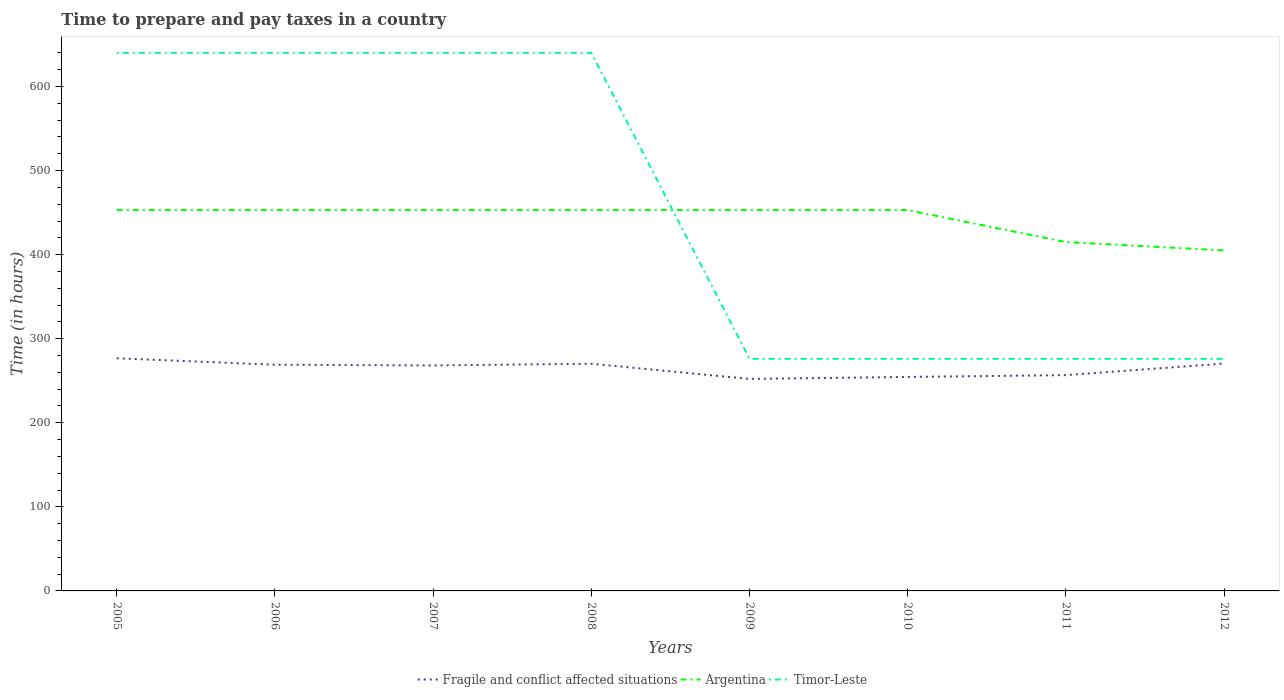Does the line corresponding to Fragile and conflict affected situations intersect with the line corresponding to Argentina?
Keep it short and to the point. No. Across all years, what is the maximum number of hours required to prepare and pay taxes in Timor-Leste?
Keep it short and to the point. 276. What is the total number of hours required to prepare and pay taxes in Argentina in the graph?
Give a very brief answer. 0. What is the difference between the highest and the second highest number of hours required to prepare and pay taxes in Timor-Leste?
Ensure brevity in your answer.  364. How many lines are there?
Provide a succinct answer. 3. Does the graph contain any zero values?
Give a very brief answer. No. Does the graph contain grids?
Your answer should be compact. No. Where does the legend appear in the graph?
Your answer should be very brief. Bottom center. What is the title of the graph?
Offer a very short reply. Time to prepare and pay taxes in a country. Does "Cyprus" appear as one of the legend labels in the graph?
Offer a terse response. No. What is the label or title of the Y-axis?
Ensure brevity in your answer.  Time (in hours). What is the Time (in hours) of Fragile and conflict affected situations in 2005?
Keep it short and to the point. 276.75. What is the Time (in hours) in Argentina in 2005?
Give a very brief answer. 453. What is the Time (in hours) of Timor-Leste in 2005?
Provide a short and direct response. 640. What is the Time (in hours) in Fragile and conflict affected situations in 2006?
Provide a short and direct response. 269.07. What is the Time (in hours) of Argentina in 2006?
Your answer should be compact. 453. What is the Time (in hours) of Timor-Leste in 2006?
Keep it short and to the point. 640. What is the Time (in hours) in Fragile and conflict affected situations in 2007?
Offer a terse response. 268.17. What is the Time (in hours) in Argentina in 2007?
Provide a short and direct response. 453. What is the Time (in hours) of Timor-Leste in 2007?
Your answer should be very brief. 640. What is the Time (in hours) in Fragile and conflict affected situations in 2008?
Offer a very short reply. 270.24. What is the Time (in hours) in Argentina in 2008?
Keep it short and to the point. 453. What is the Time (in hours) in Timor-Leste in 2008?
Your answer should be compact. 640. What is the Time (in hours) in Fragile and conflict affected situations in 2009?
Your answer should be compact. 252.17. What is the Time (in hours) of Argentina in 2009?
Offer a very short reply. 453. What is the Time (in hours) in Timor-Leste in 2009?
Offer a very short reply. 276. What is the Time (in hours) of Fragile and conflict affected situations in 2010?
Provide a succinct answer. 254.53. What is the Time (in hours) in Argentina in 2010?
Provide a succinct answer. 453. What is the Time (in hours) in Timor-Leste in 2010?
Provide a short and direct response. 276. What is the Time (in hours) in Fragile and conflict affected situations in 2011?
Ensure brevity in your answer.  256.68. What is the Time (in hours) in Argentina in 2011?
Provide a succinct answer. 415. What is the Time (in hours) in Timor-Leste in 2011?
Your answer should be compact. 276. What is the Time (in hours) in Fragile and conflict affected situations in 2012?
Provide a succinct answer. 270.48. What is the Time (in hours) in Argentina in 2012?
Your answer should be compact. 405. What is the Time (in hours) in Timor-Leste in 2012?
Provide a short and direct response. 276. Across all years, what is the maximum Time (in hours) of Fragile and conflict affected situations?
Ensure brevity in your answer.  276.75. Across all years, what is the maximum Time (in hours) of Argentina?
Give a very brief answer. 453. Across all years, what is the maximum Time (in hours) of Timor-Leste?
Your answer should be very brief. 640. Across all years, what is the minimum Time (in hours) in Fragile and conflict affected situations?
Provide a succinct answer. 252.17. Across all years, what is the minimum Time (in hours) in Argentina?
Your response must be concise. 405. Across all years, what is the minimum Time (in hours) in Timor-Leste?
Give a very brief answer. 276. What is the total Time (in hours) in Fragile and conflict affected situations in the graph?
Provide a succinct answer. 2118.1. What is the total Time (in hours) of Argentina in the graph?
Your answer should be compact. 3538. What is the total Time (in hours) of Timor-Leste in the graph?
Offer a terse response. 3664. What is the difference between the Time (in hours) in Fragile and conflict affected situations in 2005 and that in 2006?
Offer a very short reply. 7.68. What is the difference between the Time (in hours) of Timor-Leste in 2005 and that in 2006?
Your response must be concise. 0. What is the difference between the Time (in hours) in Fragile and conflict affected situations in 2005 and that in 2007?
Ensure brevity in your answer.  8.58. What is the difference between the Time (in hours) of Timor-Leste in 2005 and that in 2007?
Offer a terse response. 0. What is the difference between the Time (in hours) in Fragile and conflict affected situations in 2005 and that in 2008?
Provide a succinct answer. 6.51. What is the difference between the Time (in hours) of Timor-Leste in 2005 and that in 2008?
Keep it short and to the point. 0. What is the difference between the Time (in hours) in Fragile and conflict affected situations in 2005 and that in 2009?
Provide a short and direct response. 24.58. What is the difference between the Time (in hours) in Argentina in 2005 and that in 2009?
Your response must be concise. 0. What is the difference between the Time (in hours) in Timor-Leste in 2005 and that in 2009?
Provide a succinct answer. 364. What is the difference between the Time (in hours) of Fragile and conflict affected situations in 2005 and that in 2010?
Offer a very short reply. 22.22. What is the difference between the Time (in hours) in Argentina in 2005 and that in 2010?
Your answer should be very brief. 0. What is the difference between the Time (in hours) of Timor-Leste in 2005 and that in 2010?
Ensure brevity in your answer.  364. What is the difference between the Time (in hours) of Fragile and conflict affected situations in 2005 and that in 2011?
Offer a terse response. 20.07. What is the difference between the Time (in hours) of Timor-Leste in 2005 and that in 2011?
Your answer should be very brief. 364. What is the difference between the Time (in hours) in Fragile and conflict affected situations in 2005 and that in 2012?
Offer a terse response. 6.27. What is the difference between the Time (in hours) of Argentina in 2005 and that in 2012?
Ensure brevity in your answer.  48. What is the difference between the Time (in hours) in Timor-Leste in 2005 and that in 2012?
Provide a succinct answer. 364. What is the difference between the Time (in hours) of Fragile and conflict affected situations in 2006 and that in 2007?
Your answer should be compact. 0.9. What is the difference between the Time (in hours) of Fragile and conflict affected situations in 2006 and that in 2008?
Offer a terse response. -1.17. What is the difference between the Time (in hours) in Timor-Leste in 2006 and that in 2008?
Your answer should be compact. 0. What is the difference between the Time (in hours) in Fragile and conflict affected situations in 2006 and that in 2009?
Your answer should be compact. 16.9. What is the difference between the Time (in hours) in Timor-Leste in 2006 and that in 2009?
Offer a very short reply. 364. What is the difference between the Time (in hours) in Fragile and conflict affected situations in 2006 and that in 2010?
Your answer should be very brief. 14.54. What is the difference between the Time (in hours) of Timor-Leste in 2006 and that in 2010?
Keep it short and to the point. 364. What is the difference between the Time (in hours) in Fragile and conflict affected situations in 2006 and that in 2011?
Offer a very short reply. 12.39. What is the difference between the Time (in hours) in Argentina in 2006 and that in 2011?
Provide a succinct answer. 38. What is the difference between the Time (in hours) in Timor-Leste in 2006 and that in 2011?
Provide a short and direct response. 364. What is the difference between the Time (in hours) of Fragile and conflict affected situations in 2006 and that in 2012?
Offer a terse response. -1.42. What is the difference between the Time (in hours) of Timor-Leste in 2006 and that in 2012?
Your answer should be compact. 364. What is the difference between the Time (in hours) in Fragile and conflict affected situations in 2007 and that in 2008?
Ensure brevity in your answer.  -2.07. What is the difference between the Time (in hours) of Argentina in 2007 and that in 2008?
Give a very brief answer. 0. What is the difference between the Time (in hours) in Timor-Leste in 2007 and that in 2008?
Offer a very short reply. 0. What is the difference between the Time (in hours) in Fragile and conflict affected situations in 2007 and that in 2009?
Your answer should be very brief. 16.01. What is the difference between the Time (in hours) in Argentina in 2007 and that in 2009?
Offer a very short reply. 0. What is the difference between the Time (in hours) in Timor-Leste in 2007 and that in 2009?
Make the answer very short. 364. What is the difference between the Time (in hours) in Fragile and conflict affected situations in 2007 and that in 2010?
Offer a very short reply. 13.64. What is the difference between the Time (in hours) of Argentina in 2007 and that in 2010?
Give a very brief answer. 0. What is the difference between the Time (in hours) of Timor-Leste in 2007 and that in 2010?
Make the answer very short. 364. What is the difference between the Time (in hours) in Fragile and conflict affected situations in 2007 and that in 2011?
Your answer should be very brief. 11.49. What is the difference between the Time (in hours) of Timor-Leste in 2007 and that in 2011?
Offer a very short reply. 364. What is the difference between the Time (in hours) of Fragile and conflict affected situations in 2007 and that in 2012?
Provide a succinct answer. -2.31. What is the difference between the Time (in hours) of Argentina in 2007 and that in 2012?
Ensure brevity in your answer.  48. What is the difference between the Time (in hours) in Timor-Leste in 2007 and that in 2012?
Keep it short and to the point. 364. What is the difference between the Time (in hours) in Fragile and conflict affected situations in 2008 and that in 2009?
Offer a terse response. 18.07. What is the difference between the Time (in hours) in Argentina in 2008 and that in 2009?
Provide a short and direct response. 0. What is the difference between the Time (in hours) of Timor-Leste in 2008 and that in 2009?
Give a very brief answer. 364. What is the difference between the Time (in hours) in Fragile and conflict affected situations in 2008 and that in 2010?
Your answer should be compact. 15.71. What is the difference between the Time (in hours) of Argentina in 2008 and that in 2010?
Offer a terse response. 0. What is the difference between the Time (in hours) in Timor-Leste in 2008 and that in 2010?
Keep it short and to the point. 364. What is the difference between the Time (in hours) in Fragile and conflict affected situations in 2008 and that in 2011?
Provide a short and direct response. 13.56. What is the difference between the Time (in hours) of Timor-Leste in 2008 and that in 2011?
Your answer should be very brief. 364. What is the difference between the Time (in hours) in Fragile and conflict affected situations in 2008 and that in 2012?
Provide a short and direct response. -0.24. What is the difference between the Time (in hours) in Argentina in 2008 and that in 2012?
Make the answer very short. 48. What is the difference between the Time (in hours) of Timor-Leste in 2008 and that in 2012?
Provide a short and direct response. 364. What is the difference between the Time (in hours) of Fragile and conflict affected situations in 2009 and that in 2010?
Provide a short and direct response. -2.37. What is the difference between the Time (in hours) of Argentina in 2009 and that in 2010?
Offer a very short reply. 0. What is the difference between the Time (in hours) in Fragile and conflict affected situations in 2009 and that in 2011?
Give a very brief answer. -4.52. What is the difference between the Time (in hours) of Argentina in 2009 and that in 2011?
Your response must be concise. 38. What is the difference between the Time (in hours) in Timor-Leste in 2009 and that in 2011?
Give a very brief answer. 0. What is the difference between the Time (in hours) of Fragile and conflict affected situations in 2009 and that in 2012?
Your answer should be compact. -18.32. What is the difference between the Time (in hours) in Argentina in 2009 and that in 2012?
Your answer should be compact. 48. What is the difference between the Time (in hours) in Fragile and conflict affected situations in 2010 and that in 2011?
Offer a very short reply. -2.15. What is the difference between the Time (in hours) in Argentina in 2010 and that in 2011?
Ensure brevity in your answer.  38. What is the difference between the Time (in hours) in Fragile and conflict affected situations in 2010 and that in 2012?
Offer a terse response. -15.95. What is the difference between the Time (in hours) of Fragile and conflict affected situations in 2011 and that in 2012?
Offer a very short reply. -13.8. What is the difference between the Time (in hours) of Argentina in 2011 and that in 2012?
Your response must be concise. 10. What is the difference between the Time (in hours) in Timor-Leste in 2011 and that in 2012?
Your answer should be compact. 0. What is the difference between the Time (in hours) in Fragile and conflict affected situations in 2005 and the Time (in hours) in Argentina in 2006?
Keep it short and to the point. -176.25. What is the difference between the Time (in hours) in Fragile and conflict affected situations in 2005 and the Time (in hours) in Timor-Leste in 2006?
Offer a very short reply. -363.25. What is the difference between the Time (in hours) of Argentina in 2005 and the Time (in hours) of Timor-Leste in 2006?
Provide a short and direct response. -187. What is the difference between the Time (in hours) in Fragile and conflict affected situations in 2005 and the Time (in hours) in Argentina in 2007?
Give a very brief answer. -176.25. What is the difference between the Time (in hours) in Fragile and conflict affected situations in 2005 and the Time (in hours) in Timor-Leste in 2007?
Give a very brief answer. -363.25. What is the difference between the Time (in hours) of Argentina in 2005 and the Time (in hours) of Timor-Leste in 2007?
Give a very brief answer. -187. What is the difference between the Time (in hours) in Fragile and conflict affected situations in 2005 and the Time (in hours) in Argentina in 2008?
Make the answer very short. -176.25. What is the difference between the Time (in hours) of Fragile and conflict affected situations in 2005 and the Time (in hours) of Timor-Leste in 2008?
Provide a succinct answer. -363.25. What is the difference between the Time (in hours) of Argentina in 2005 and the Time (in hours) of Timor-Leste in 2008?
Your answer should be very brief. -187. What is the difference between the Time (in hours) in Fragile and conflict affected situations in 2005 and the Time (in hours) in Argentina in 2009?
Provide a short and direct response. -176.25. What is the difference between the Time (in hours) in Fragile and conflict affected situations in 2005 and the Time (in hours) in Timor-Leste in 2009?
Offer a very short reply. 0.75. What is the difference between the Time (in hours) in Argentina in 2005 and the Time (in hours) in Timor-Leste in 2009?
Your answer should be very brief. 177. What is the difference between the Time (in hours) in Fragile and conflict affected situations in 2005 and the Time (in hours) in Argentina in 2010?
Keep it short and to the point. -176.25. What is the difference between the Time (in hours) of Fragile and conflict affected situations in 2005 and the Time (in hours) of Timor-Leste in 2010?
Offer a very short reply. 0.75. What is the difference between the Time (in hours) of Argentina in 2005 and the Time (in hours) of Timor-Leste in 2010?
Ensure brevity in your answer.  177. What is the difference between the Time (in hours) of Fragile and conflict affected situations in 2005 and the Time (in hours) of Argentina in 2011?
Provide a short and direct response. -138.25. What is the difference between the Time (in hours) in Fragile and conflict affected situations in 2005 and the Time (in hours) in Timor-Leste in 2011?
Provide a short and direct response. 0.75. What is the difference between the Time (in hours) in Argentina in 2005 and the Time (in hours) in Timor-Leste in 2011?
Make the answer very short. 177. What is the difference between the Time (in hours) of Fragile and conflict affected situations in 2005 and the Time (in hours) of Argentina in 2012?
Provide a short and direct response. -128.25. What is the difference between the Time (in hours) of Argentina in 2005 and the Time (in hours) of Timor-Leste in 2012?
Offer a terse response. 177. What is the difference between the Time (in hours) of Fragile and conflict affected situations in 2006 and the Time (in hours) of Argentina in 2007?
Make the answer very short. -183.93. What is the difference between the Time (in hours) of Fragile and conflict affected situations in 2006 and the Time (in hours) of Timor-Leste in 2007?
Keep it short and to the point. -370.93. What is the difference between the Time (in hours) of Argentina in 2006 and the Time (in hours) of Timor-Leste in 2007?
Offer a terse response. -187. What is the difference between the Time (in hours) in Fragile and conflict affected situations in 2006 and the Time (in hours) in Argentina in 2008?
Keep it short and to the point. -183.93. What is the difference between the Time (in hours) in Fragile and conflict affected situations in 2006 and the Time (in hours) in Timor-Leste in 2008?
Give a very brief answer. -370.93. What is the difference between the Time (in hours) in Argentina in 2006 and the Time (in hours) in Timor-Leste in 2008?
Keep it short and to the point. -187. What is the difference between the Time (in hours) of Fragile and conflict affected situations in 2006 and the Time (in hours) of Argentina in 2009?
Provide a succinct answer. -183.93. What is the difference between the Time (in hours) in Fragile and conflict affected situations in 2006 and the Time (in hours) in Timor-Leste in 2009?
Make the answer very short. -6.93. What is the difference between the Time (in hours) of Argentina in 2006 and the Time (in hours) of Timor-Leste in 2009?
Offer a terse response. 177. What is the difference between the Time (in hours) in Fragile and conflict affected situations in 2006 and the Time (in hours) in Argentina in 2010?
Give a very brief answer. -183.93. What is the difference between the Time (in hours) of Fragile and conflict affected situations in 2006 and the Time (in hours) of Timor-Leste in 2010?
Your answer should be very brief. -6.93. What is the difference between the Time (in hours) in Argentina in 2006 and the Time (in hours) in Timor-Leste in 2010?
Your answer should be compact. 177. What is the difference between the Time (in hours) in Fragile and conflict affected situations in 2006 and the Time (in hours) in Argentina in 2011?
Your answer should be compact. -145.93. What is the difference between the Time (in hours) of Fragile and conflict affected situations in 2006 and the Time (in hours) of Timor-Leste in 2011?
Your response must be concise. -6.93. What is the difference between the Time (in hours) of Argentina in 2006 and the Time (in hours) of Timor-Leste in 2011?
Offer a terse response. 177. What is the difference between the Time (in hours) in Fragile and conflict affected situations in 2006 and the Time (in hours) in Argentina in 2012?
Your answer should be very brief. -135.93. What is the difference between the Time (in hours) of Fragile and conflict affected situations in 2006 and the Time (in hours) of Timor-Leste in 2012?
Your answer should be very brief. -6.93. What is the difference between the Time (in hours) in Argentina in 2006 and the Time (in hours) in Timor-Leste in 2012?
Your answer should be compact. 177. What is the difference between the Time (in hours) in Fragile and conflict affected situations in 2007 and the Time (in hours) in Argentina in 2008?
Ensure brevity in your answer.  -184.83. What is the difference between the Time (in hours) of Fragile and conflict affected situations in 2007 and the Time (in hours) of Timor-Leste in 2008?
Give a very brief answer. -371.83. What is the difference between the Time (in hours) in Argentina in 2007 and the Time (in hours) in Timor-Leste in 2008?
Make the answer very short. -187. What is the difference between the Time (in hours) in Fragile and conflict affected situations in 2007 and the Time (in hours) in Argentina in 2009?
Make the answer very short. -184.83. What is the difference between the Time (in hours) of Fragile and conflict affected situations in 2007 and the Time (in hours) of Timor-Leste in 2009?
Keep it short and to the point. -7.83. What is the difference between the Time (in hours) in Argentina in 2007 and the Time (in hours) in Timor-Leste in 2009?
Your answer should be very brief. 177. What is the difference between the Time (in hours) in Fragile and conflict affected situations in 2007 and the Time (in hours) in Argentina in 2010?
Your answer should be very brief. -184.83. What is the difference between the Time (in hours) in Fragile and conflict affected situations in 2007 and the Time (in hours) in Timor-Leste in 2010?
Keep it short and to the point. -7.83. What is the difference between the Time (in hours) of Argentina in 2007 and the Time (in hours) of Timor-Leste in 2010?
Ensure brevity in your answer.  177. What is the difference between the Time (in hours) of Fragile and conflict affected situations in 2007 and the Time (in hours) of Argentina in 2011?
Your answer should be very brief. -146.83. What is the difference between the Time (in hours) of Fragile and conflict affected situations in 2007 and the Time (in hours) of Timor-Leste in 2011?
Ensure brevity in your answer.  -7.83. What is the difference between the Time (in hours) of Argentina in 2007 and the Time (in hours) of Timor-Leste in 2011?
Offer a very short reply. 177. What is the difference between the Time (in hours) of Fragile and conflict affected situations in 2007 and the Time (in hours) of Argentina in 2012?
Make the answer very short. -136.83. What is the difference between the Time (in hours) in Fragile and conflict affected situations in 2007 and the Time (in hours) in Timor-Leste in 2012?
Give a very brief answer. -7.83. What is the difference between the Time (in hours) in Argentina in 2007 and the Time (in hours) in Timor-Leste in 2012?
Offer a terse response. 177. What is the difference between the Time (in hours) in Fragile and conflict affected situations in 2008 and the Time (in hours) in Argentina in 2009?
Provide a short and direct response. -182.76. What is the difference between the Time (in hours) of Fragile and conflict affected situations in 2008 and the Time (in hours) of Timor-Leste in 2009?
Your answer should be compact. -5.76. What is the difference between the Time (in hours) in Argentina in 2008 and the Time (in hours) in Timor-Leste in 2009?
Your answer should be very brief. 177. What is the difference between the Time (in hours) in Fragile and conflict affected situations in 2008 and the Time (in hours) in Argentina in 2010?
Make the answer very short. -182.76. What is the difference between the Time (in hours) in Fragile and conflict affected situations in 2008 and the Time (in hours) in Timor-Leste in 2010?
Ensure brevity in your answer.  -5.76. What is the difference between the Time (in hours) of Argentina in 2008 and the Time (in hours) of Timor-Leste in 2010?
Offer a terse response. 177. What is the difference between the Time (in hours) of Fragile and conflict affected situations in 2008 and the Time (in hours) of Argentina in 2011?
Keep it short and to the point. -144.76. What is the difference between the Time (in hours) in Fragile and conflict affected situations in 2008 and the Time (in hours) in Timor-Leste in 2011?
Your response must be concise. -5.76. What is the difference between the Time (in hours) in Argentina in 2008 and the Time (in hours) in Timor-Leste in 2011?
Keep it short and to the point. 177. What is the difference between the Time (in hours) of Fragile and conflict affected situations in 2008 and the Time (in hours) of Argentina in 2012?
Make the answer very short. -134.76. What is the difference between the Time (in hours) of Fragile and conflict affected situations in 2008 and the Time (in hours) of Timor-Leste in 2012?
Provide a short and direct response. -5.76. What is the difference between the Time (in hours) of Argentina in 2008 and the Time (in hours) of Timor-Leste in 2012?
Provide a short and direct response. 177. What is the difference between the Time (in hours) in Fragile and conflict affected situations in 2009 and the Time (in hours) in Argentina in 2010?
Give a very brief answer. -200.83. What is the difference between the Time (in hours) of Fragile and conflict affected situations in 2009 and the Time (in hours) of Timor-Leste in 2010?
Provide a short and direct response. -23.83. What is the difference between the Time (in hours) of Argentina in 2009 and the Time (in hours) of Timor-Leste in 2010?
Your answer should be very brief. 177. What is the difference between the Time (in hours) in Fragile and conflict affected situations in 2009 and the Time (in hours) in Argentina in 2011?
Your response must be concise. -162.83. What is the difference between the Time (in hours) in Fragile and conflict affected situations in 2009 and the Time (in hours) in Timor-Leste in 2011?
Your response must be concise. -23.83. What is the difference between the Time (in hours) of Argentina in 2009 and the Time (in hours) of Timor-Leste in 2011?
Your response must be concise. 177. What is the difference between the Time (in hours) in Fragile and conflict affected situations in 2009 and the Time (in hours) in Argentina in 2012?
Give a very brief answer. -152.83. What is the difference between the Time (in hours) in Fragile and conflict affected situations in 2009 and the Time (in hours) in Timor-Leste in 2012?
Provide a succinct answer. -23.83. What is the difference between the Time (in hours) of Argentina in 2009 and the Time (in hours) of Timor-Leste in 2012?
Make the answer very short. 177. What is the difference between the Time (in hours) of Fragile and conflict affected situations in 2010 and the Time (in hours) of Argentina in 2011?
Offer a very short reply. -160.47. What is the difference between the Time (in hours) of Fragile and conflict affected situations in 2010 and the Time (in hours) of Timor-Leste in 2011?
Give a very brief answer. -21.47. What is the difference between the Time (in hours) of Argentina in 2010 and the Time (in hours) of Timor-Leste in 2011?
Keep it short and to the point. 177. What is the difference between the Time (in hours) in Fragile and conflict affected situations in 2010 and the Time (in hours) in Argentina in 2012?
Ensure brevity in your answer.  -150.47. What is the difference between the Time (in hours) in Fragile and conflict affected situations in 2010 and the Time (in hours) in Timor-Leste in 2012?
Your answer should be compact. -21.47. What is the difference between the Time (in hours) in Argentina in 2010 and the Time (in hours) in Timor-Leste in 2012?
Provide a short and direct response. 177. What is the difference between the Time (in hours) of Fragile and conflict affected situations in 2011 and the Time (in hours) of Argentina in 2012?
Your answer should be very brief. -148.32. What is the difference between the Time (in hours) of Fragile and conflict affected situations in 2011 and the Time (in hours) of Timor-Leste in 2012?
Give a very brief answer. -19.32. What is the difference between the Time (in hours) of Argentina in 2011 and the Time (in hours) of Timor-Leste in 2012?
Provide a succinct answer. 139. What is the average Time (in hours) in Fragile and conflict affected situations per year?
Your answer should be compact. 264.76. What is the average Time (in hours) in Argentina per year?
Give a very brief answer. 442.25. What is the average Time (in hours) of Timor-Leste per year?
Give a very brief answer. 458. In the year 2005, what is the difference between the Time (in hours) in Fragile and conflict affected situations and Time (in hours) in Argentina?
Ensure brevity in your answer.  -176.25. In the year 2005, what is the difference between the Time (in hours) in Fragile and conflict affected situations and Time (in hours) in Timor-Leste?
Provide a succinct answer. -363.25. In the year 2005, what is the difference between the Time (in hours) in Argentina and Time (in hours) in Timor-Leste?
Your answer should be compact. -187. In the year 2006, what is the difference between the Time (in hours) of Fragile and conflict affected situations and Time (in hours) of Argentina?
Your answer should be very brief. -183.93. In the year 2006, what is the difference between the Time (in hours) in Fragile and conflict affected situations and Time (in hours) in Timor-Leste?
Make the answer very short. -370.93. In the year 2006, what is the difference between the Time (in hours) in Argentina and Time (in hours) in Timor-Leste?
Your answer should be very brief. -187. In the year 2007, what is the difference between the Time (in hours) in Fragile and conflict affected situations and Time (in hours) in Argentina?
Your response must be concise. -184.83. In the year 2007, what is the difference between the Time (in hours) in Fragile and conflict affected situations and Time (in hours) in Timor-Leste?
Keep it short and to the point. -371.83. In the year 2007, what is the difference between the Time (in hours) of Argentina and Time (in hours) of Timor-Leste?
Your response must be concise. -187. In the year 2008, what is the difference between the Time (in hours) of Fragile and conflict affected situations and Time (in hours) of Argentina?
Give a very brief answer. -182.76. In the year 2008, what is the difference between the Time (in hours) in Fragile and conflict affected situations and Time (in hours) in Timor-Leste?
Make the answer very short. -369.76. In the year 2008, what is the difference between the Time (in hours) of Argentina and Time (in hours) of Timor-Leste?
Provide a succinct answer. -187. In the year 2009, what is the difference between the Time (in hours) of Fragile and conflict affected situations and Time (in hours) of Argentina?
Keep it short and to the point. -200.83. In the year 2009, what is the difference between the Time (in hours) of Fragile and conflict affected situations and Time (in hours) of Timor-Leste?
Keep it short and to the point. -23.83. In the year 2009, what is the difference between the Time (in hours) in Argentina and Time (in hours) in Timor-Leste?
Your response must be concise. 177. In the year 2010, what is the difference between the Time (in hours) of Fragile and conflict affected situations and Time (in hours) of Argentina?
Provide a short and direct response. -198.47. In the year 2010, what is the difference between the Time (in hours) in Fragile and conflict affected situations and Time (in hours) in Timor-Leste?
Provide a short and direct response. -21.47. In the year 2010, what is the difference between the Time (in hours) in Argentina and Time (in hours) in Timor-Leste?
Keep it short and to the point. 177. In the year 2011, what is the difference between the Time (in hours) of Fragile and conflict affected situations and Time (in hours) of Argentina?
Ensure brevity in your answer.  -158.32. In the year 2011, what is the difference between the Time (in hours) in Fragile and conflict affected situations and Time (in hours) in Timor-Leste?
Your response must be concise. -19.32. In the year 2011, what is the difference between the Time (in hours) of Argentina and Time (in hours) of Timor-Leste?
Make the answer very short. 139. In the year 2012, what is the difference between the Time (in hours) of Fragile and conflict affected situations and Time (in hours) of Argentina?
Your response must be concise. -134.52. In the year 2012, what is the difference between the Time (in hours) of Fragile and conflict affected situations and Time (in hours) of Timor-Leste?
Your answer should be very brief. -5.52. In the year 2012, what is the difference between the Time (in hours) of Argentina and Time (in hours) of Timor-Leste?
Keep it short and to the point. 129. What is the ratio of the Time (in hours) of Fragile and conflict affected situations in 2005 to that in 2006?
Provide a succinct answer. 1.03. What is the ratio of the Time (in hours) of Argentina in 2005 to that in 2006?
Your answer should be very brief. 1. What is the ratio of the Time (in hours) in Timor-Leste in 2005 to that in 2006?
Make the answer very short. 1. What is the ratio of the Time (in hours) of Fragile and conflict affected situations in 2005 to that in 2007?
Offer a very short reply. 1.03. What is the ratio of the Time (in hours) of Argentina in 2005 to that in 2007?
Your answer should be very brief. 1. What is the ratio of the Time (in hours) in Fragile and conflict affected situations in 2005 to that in 2008?
Make the answer very short. 1.02. What is the ratio of the Time (in hours) of Argentina in 2005 to that in 2008?
Offer a terse response. 1. What is the ratio of the Time (in hours) in Timor-Leste in 2005 to that in 2008?
Ensure brevity in your answer.  1. What is the ratio of the Time (in hours) of Fragile and conflict affected situations in 2005 to that in 2009?
Keep it short and to the point. 1.1. What is the ratio of the Time (in hours) in Argentina in 2005 to that in 2009?
Ensure brevity in your answer.  1. What is the ratio of the Time (in hours) in Timor-Leste in 2005 to that in 2009?
Your response must be concise. 2.32. What is the ratio of the Time (in hours) in Fragile and conflict affected situations in 2005 to that in 2010?
Offer a terse response. 1.09. What is the ratio of the Time (in hours) of Timor-Leste in 2005 to that in 2010?
Make the answer very short. 2.32. What is the ratio of the Time (in hours) in Fragile and conflict affected situations in 2005 to that in 2011?
Keep it short and to the point. 1.08. What is the ratio of the Time (in hours) of Argentina in 2005 to that in 2011?
Make the answer very short. 1.09. What is the ratio of the Time (in hours) of Timor-Leste in 2005 to that in 2011?
Provide a short and direct response. 2.32. What is the ratio of the Time (in hours) of Fragile and conflict affected situations in 2005 to that in 2012?
Your answer should be compact. 1.02. What is the ratio of the Time (in hours) in Argentina in 2005 to that in 2012?
Provide a succinct answer. 1.12. What is the ratio of the Time (in hours) of Timor-Leste in 2005 to that in 2012?
Offer a terse response. 2.32. What is the ratio of the Time (in hours) of Timor-Leste in 2006 to that in 2008?
Offer a very short reply. 1. What is the ratio of the Time (in hours) of Fragile and conflict affected situations in 2006 to that in 2009?
Your answer should be very brief. 1.07. What is the ratio of the Time (in hours) of Timor-Leste in 2006 to that in 2009?
Your response must be concise. 2.32. What is the ratio of the Time (in hours) of Fragile and conflict affected situations in 2006 to that in 2010?
Your answer should be compact. 1.06. What is the ratio of the Time (in hours) in Argentina in 2006 to that in 2010?
Provide a succinct answer. 1. What is the ratio of the Time (in hours) of Timor-Leste in 2006 to that in 2010?
Your answer should be compact. 2.32. What is the ratio of the Time (in hours) of Fragile and conflict affected situations in 2006 to that in 2011?
Offer a very short reply. 1.05. What is the ratio of the Time (in hours) in Argentina in 2006 to that in 2011?
Provide a succinct answer. 1.09. What is the ratio of the Time (in hours) of Timor-Leste in 2006 to that in 2011?
Your response must be concise. 2.32. What is the ratio of the Time (in hours) in Fragile and conflict affected situations in 2006 to that in 2012?
Your response must be concise. 0.99. What is the ratio of the Time (in hours) of Argentina in 2006 to that in 2012?
Make the answer very short. 1.12. What is the ratio of the Time (in hours) of Timor-Leste in 2006 to that in 2012?
Make the answer very short. 2.32. What is the ratio of the Time (in hours) of Fragile and conflict affected situations in 2007 to that in 2008?
Offer a terse response. 0.99. What is the ratio of the Time (in hours) of Argentina in 2007 to that in 2008?
Give a very brief answer. 1. What is the ratio of the Time (in hours) in Timor-Leste in 2007 to that in 2008?
Offer a very short reply. 1. What is the ratio of the Time (in hours) of Fragile and conflict affected situations in 2007 to that in 2009?
Offer a terse response. 1.06. What is the ratio of the Time (in hours) in Timor-Leste in 2007 to that in 2009?
Your response must be concise. 2.32. What is the ratio of the Time (in hours) in Fragile and conflict affected situations in 2007 to that in 2010?
Ensure brevity in your answer.  1.05. What is the ratio of the Time (in hours) of Argentina in 2007 to that in 2010?
Ensure brevity in your answer.  1. What is the ratio of the Time (in hours) of Timor-Leste in 2007 to that in 2010?
Provide a short and direct response. 2.32. What is the ratio of the Time (in hours) of Fragile and conflict affected situations in 2007 to that in 2011?
Offer a terse response. 1.04. What is the ratio of the Time (in hours) of Argentina in 2007 to that in 2011?
Ensure brevity in your answer.  1.09. What is the ratio of the Time (in hours) of Timor-Leste in 2007 to that in 2011?
Make the answer very short. 2.32. What is the ratio of the Time (in hours) of Fragile and conflict affected situations in 2007 to that in 2012?
Your answer should be compact. 0.99. What is the ratio of the Time (in hours) of Argentina in 2007 to that in 2012?
Provide a succinct answer. 1.12. What is the ratio of the Time (in hours) in Timor-Leste in 2007 to that in 2012?
Offer a terse response. 2.32. What is the ratio of the Time (in hours) of Fragile and conflict affected situations in 2008 to that in 2009?
Your answer should be very brief. 1.07. What is the ratio of the Time (in hours) in Timor-Leste in 2008 to that in 2009?
Give a very brief answer. 2.32. What is the ratio of the Time (in hours) of Fragile and conflict affected situations in 2008 to that in 2010?
Keep it short and to the point. 1.06. What is the ratio of the Time (in hours) in Argentina in 2008 to that in 2010?
Ensure brevity in your answer.  1. What is the ratio of the Time (in hours) of Timor-Leste in 2008 to that in 2010?
Ensure brevity in your answer.  2.32. What is the ratio of the Time (in hours) in Fragile and conflict affected situations in 2008 to that in 2011?
Provide a succinct answer. 1.05. What is the ratio of the Time (in hours) of Argentina in 2008 to that in 2011?
Give a very brief answer. 1.09. What is the ratio of the Time (in hours) in Timor-Leste in 2008 to that in 2011?
Give a very brief answer. 2.32. What is the ratio of the Time (in hours) in Argentina in 2008 to that in 2012?
Ensure brevity in your answer.  1.12. What is the ratio of the Time (in hours) in Timor-Leste in 2008 to that in 2012?
Your response must be concise. 2.32. What is the ratio of the Time (in hours) in Timor-Leste in 2009 to that in 2010?
Offer a terse response. 1. What is the ratio of the Time (in hours) of Fragile and conflict affected situations in 2009 to that in 2011?
Keep it short and to the point. 0.98. What is the ratio of the Time (in hours) in Argentina in 2009 to that in 2011?
Provide a short and direct response. 1.09. What is the ratio of the Time (in hours) of Fragile and conflict affected situations in 2009 to that in 2012?
Keep it short and to the point. 0.93. What is the ratio of the Time (in hours) of Argentina in 2009 to that in 2012?
Offer a terse response. 1.12. What is the ratio of the Time (in hours) in Timor-Leste in 2009 to that in 2012?
Your answer should be very brief. 1. What is the ratio of the Time (in hours) in Fragile and conflict affected situations in 2010 to that in 2011?
Give a very brief answer. 0.99. What is the ratio of the Time (in hours) in Argentina in 2010 to that in 2011?
Your response must be concise. 1.09. What is the ratio of the Time (in hours) in Fragile and conflict affected situations in 2010 to that in 2012?
Keep it short and to the point. 0.94. What is the ratio of the Time (in hours) of Argentina in 2010 to that in 2012?
Ensure brevity in your answer.  1.12. What is the ratio of the Time (in hours) of Fragile and conflict affected situations in 2011 to that in 2012?
Offer a very short reply. 0.95. What is the ratio of the Time (in hours) of Argentina in 2011 to that in 2012?
Provide a short and direct response. 1.02. What is the difference between the highest and the second highest Time (in hours) in Fragile and conflict affected situations?
Your response must be concise. 6.27. What is the difference between the highest and the second highest Time (in hours) of Argentina?
Your response must be concise. 0. What is the difference between the highest and the lowest Time (in hours) in Fragile and conflict affected situations?
Provide a short and direct response. 24.58. What is the difference between the highest and the lowest Time (in hours) of Timor-Leste?
Offer a terse response. 364. 